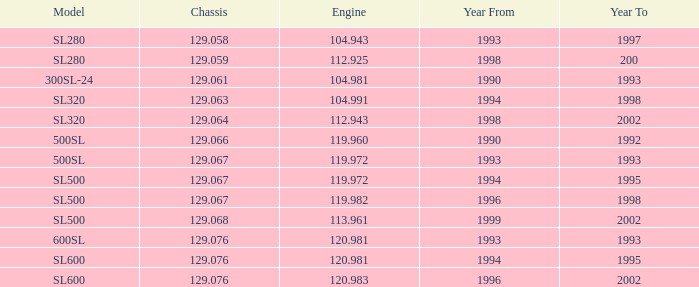Which Engine has a Model of sl500, and a Chassis smaller than 129.067? None. 